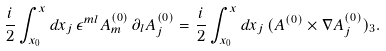Convert formula to latex. <formula><loc_0><loc_0><loc_500><loc_500>\frac { i } { 2 } \int _ { x _ { 0 } } ^ { x } d x _ { j } \, \epsilon ^ { m l } A ^ { ( 0 ) } _ { m } \, \partial _ { l } A ^ { ( 0 ) } _ { j } = \frac { i } { 2 } \int _ { x _ { 0 } } ^ { x } d x _ { j } \, ( { A } ^ { ( 0 ) } \times \nabla A ^ { ( 0 ) } _ { j } ) _ { 3 } .</formula> 